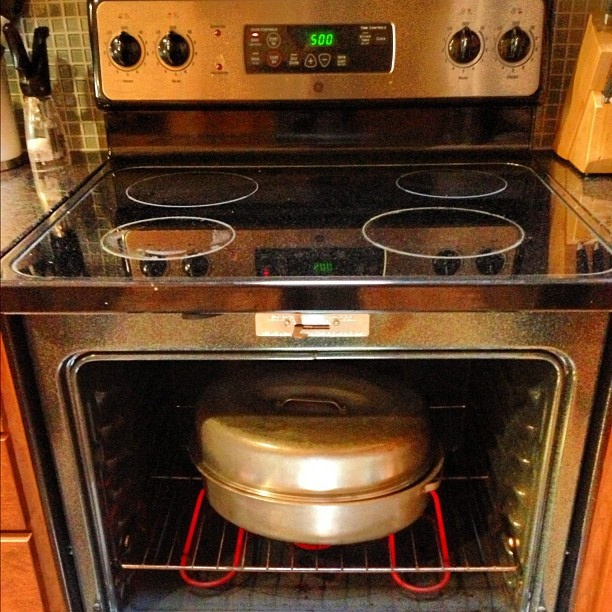Describe the objects in this image and their specific colors. I can see oven in black, maroon, and brown tones, cup in black, olive, maroon, and tan tones, knife in black, maroon, and gray tones, and knife in black, olive, and gray tones in this image. 